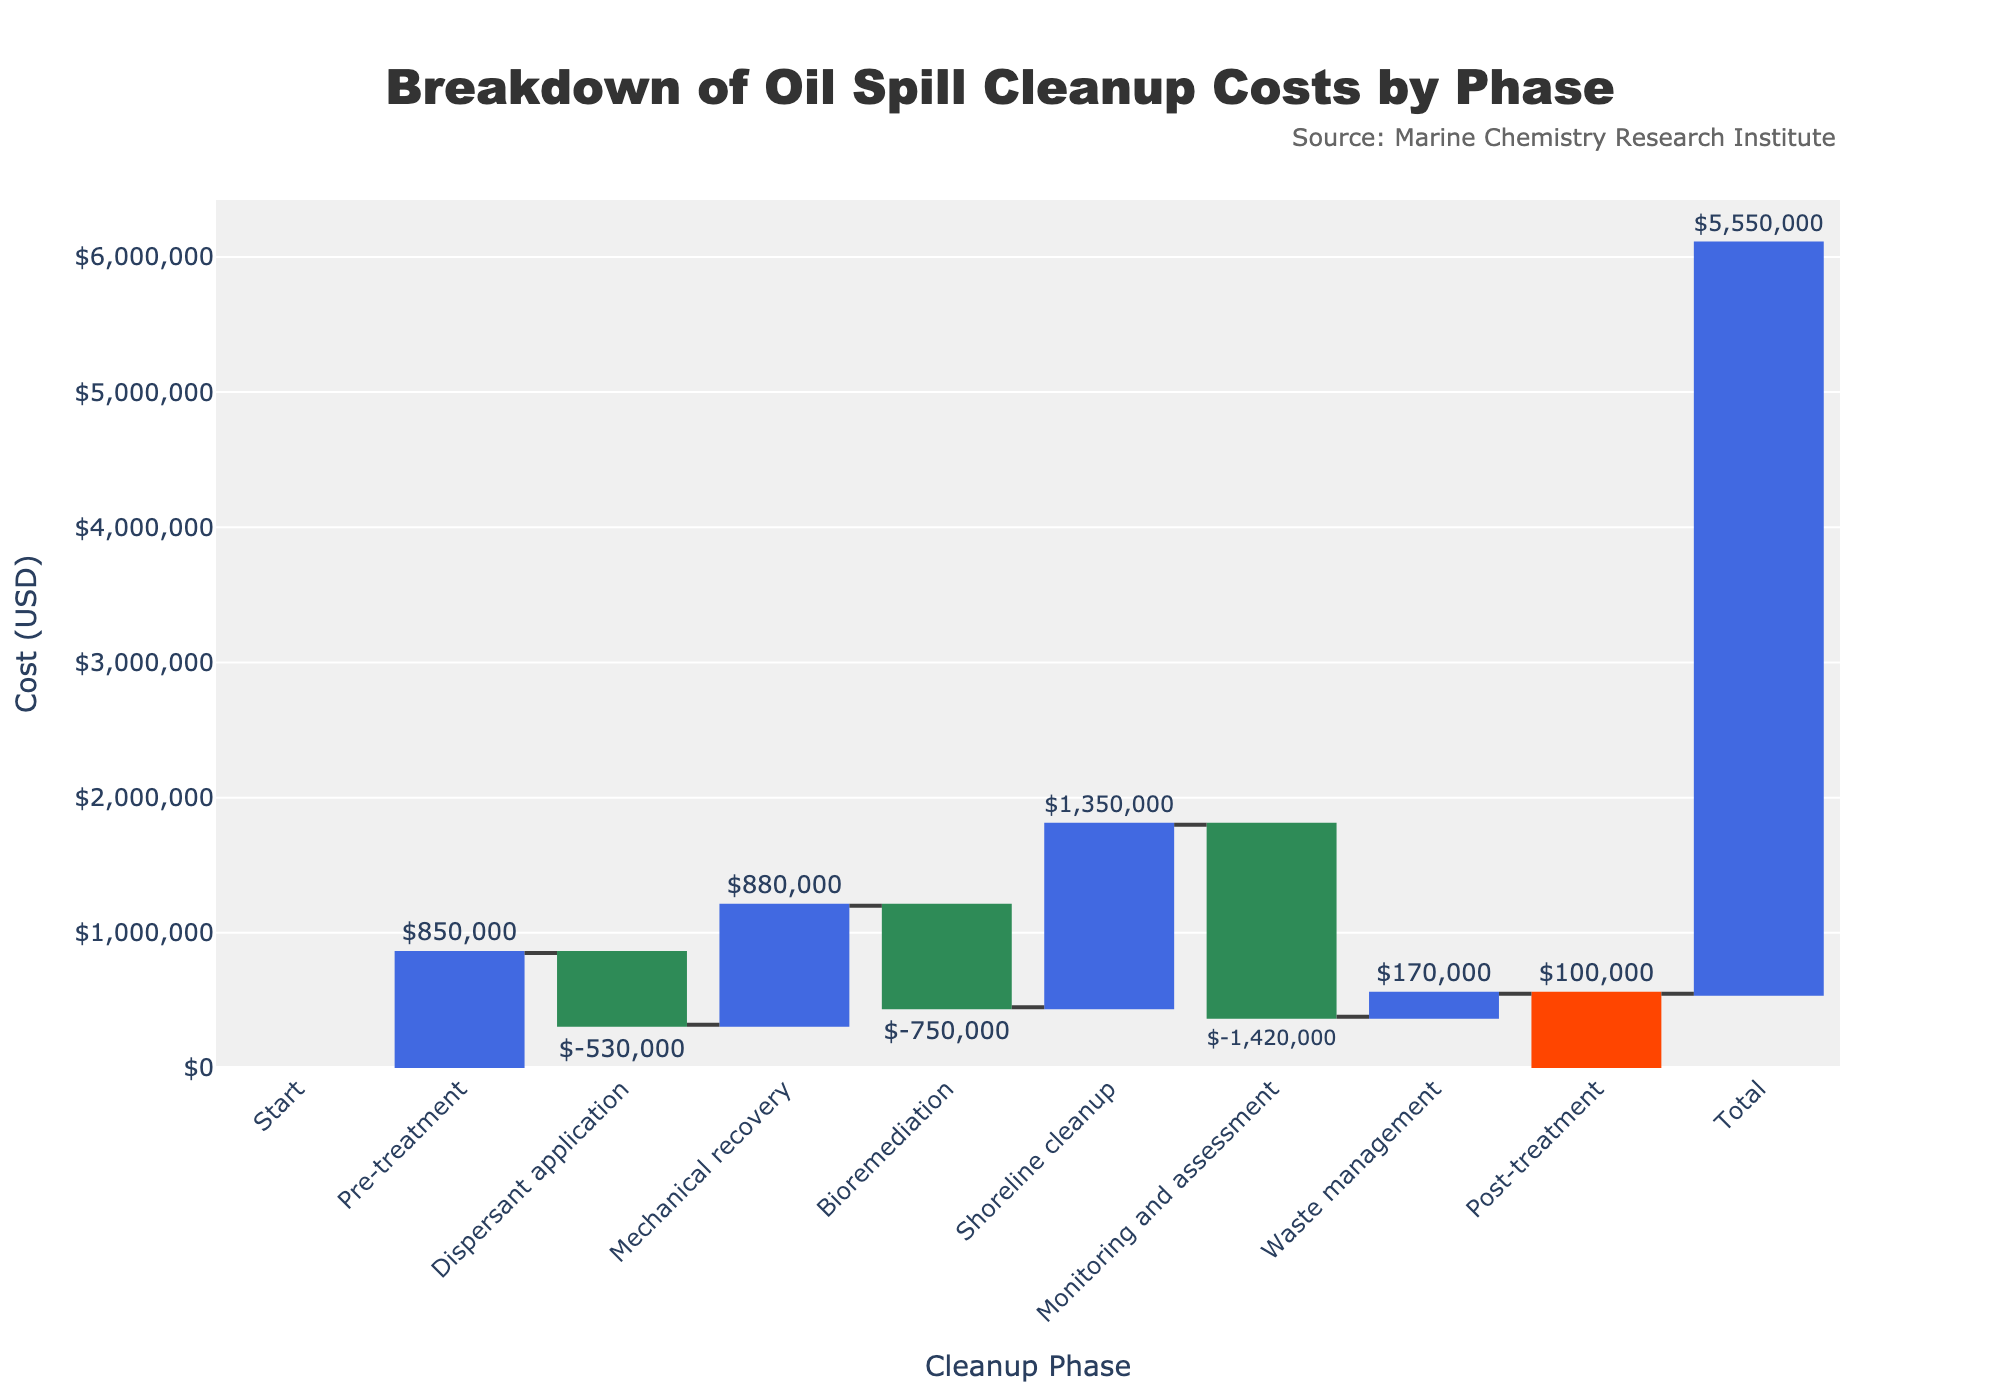What's the title of the chart? The title of the chart is mentioned at the top, centered. It provides an overview of the contents of the chart which is about the various phases of oil spill cleanup costs.
Answer: Breakdown of Oil Spill Cleanup Costs by Phase What is the cost for mechanical recovery? The chart includes each phase and its corresponding cost breakdown represented visually. Looking at the mechanical recovery phase, the cost is clearly labeled.
Answer: $1,200,000 Which cleanup phase has the highest cost? By comparing the heights of the bars, we can observe which phase has the tallest bar representing the highest cost.
Answer: Shoreline cleanup What is the total cost of the cleanup? The total bar at the end of the chart represents the sum of all the costs indicated by other bars. The value is clearly marked at the end of the chart.
Answer: $6,200,000 How does the cost of bioremediation compare to waste management? To compare, we check the lengths of the bars associated with bioremediation and waste management. Visually, bioremediation has a shorter bar than waste management.
Answer: Waste management is higher What is the incremental cost added for monitoring and assessment? This can be found by identifying the specific bar labeled as monitoring and assessment and reading the value outside the bar.
Answer: $380,000 How much more expensive is shoreline cleanup compared to pre-treatment? First, identify the costs of shoreline cleanup and pre-treatment. Then, subtract the pre-treatment cost from the shoreline cleanup cost to get the difference.
Answer: $950,000 What is the cumulative cost before the monitoring and assessment phase? Add up costs from all phases preceding the monitoring and assessment phase: Pre-treatment, Dispersant application, Mechanical recovery, Bioremediation, and Shoreline cleanup. The sum of these gives the cumulative cost before that phase.
Answer: $4,350,000 Which phases have costs below $500,000? Identify and compare the labeled values and lengths of bars to see which fall below $500,000. The bars for dispersant application and bioremediation meet this criterion.
Answer: Dispersant application and Bioremediation How much does post-treatment contribute to the total cost? Find the bar labeled post-treatment and observe its value. This contribution can be directly read off from the chart.
Answer: $650,000 